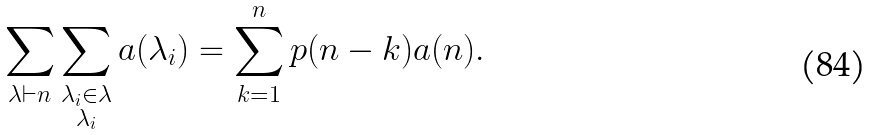<formula> <loc_0><loc_0><loc_500><loc_500>\sum _ { \lambda \vdash n } \sum _ { \substack { \lambda _ { i } \in \lambda \\ \lambda _ { i } } } a ( \lambda _ { i } ) = \sum _ { k = 1 } ^ { n } p ( n - k ) a ( n ) .</formula> 